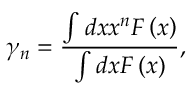<formula> <loc_0><loc_0><loc_500><loc_500>\gamma _ { n } = \frac { \int d x x ^ { n } F \left ( x \right ) } { \int d x F \left ( x \right ) } ,</formula> 